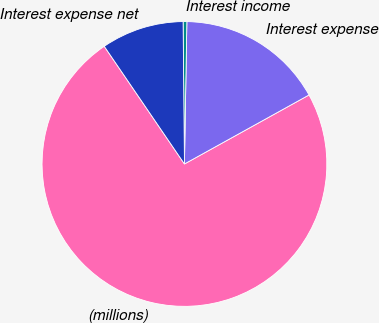Convert chart. <chart><loc_0><loc_0><loc_500><loc_500><pie_chart><fcel>(millions)<fcel>Interest expense<fcel>Interest income<fcel>Interest expense net<nl><fcel>73.53%<fcel>16.68%<fcel>0.42%<fcel>9.37%<nl></chart> 